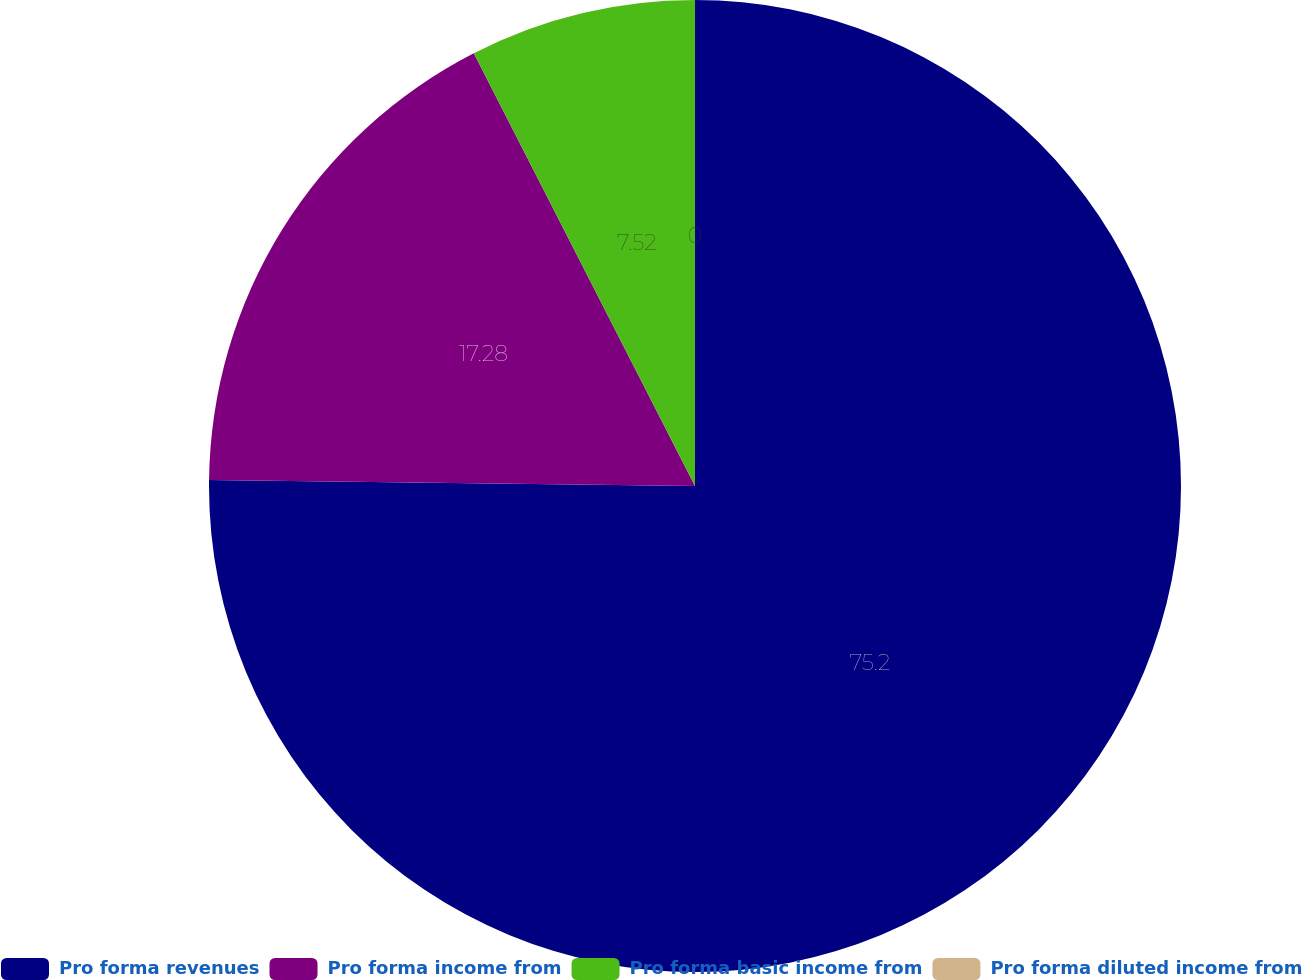Convert chart to OTSL. <chart><loc_0><loc_0><loc_500><loc_500><pie_chart><fcel>Pro forma revenues<fcel>Pro forma income from<fcel>Pro forma basic income from<fcel>Pro forma diluted income from<nl><fcel>75.2%<fcel>17.28%<fcel>7.52%<fcel>0.0%<nl></chart> 